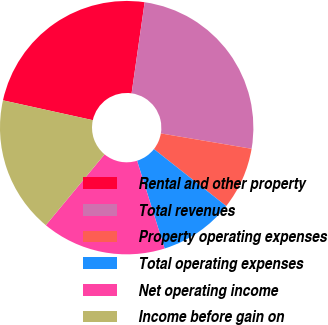<chart> <loc_0><loc_0><loc_500><loc_500><pie_chart><fcel>Rental and other property<fcel>Total revenues<fcel>Property operating expenses<fcel>Total operating expenses<fcel>Net operating income<fcel>Income before gain on<nl><fcel>23.81%<fcel>25.4%<fcel>7.95%<fcel>9.54%<fcel>15.86%<fcel>17.44%<nl></chart> 